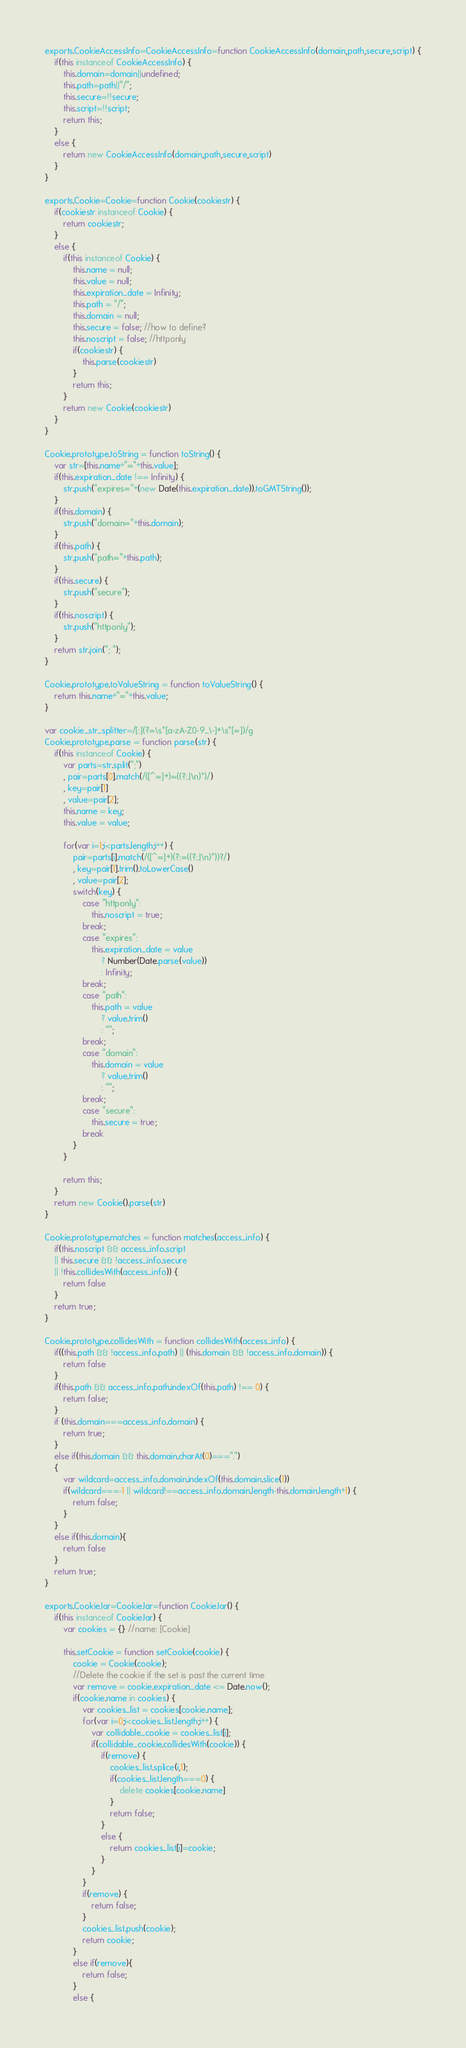<code> <loc_0><loc_0><loc_500><loc_500><_JavaScript_>exports.CookieAccessInfo=CookieAccessInfo=function CookieAccessInfo(domain,path,secure,script) {
    if(this instanceof CookieAccessInfo) {
    	this.domain=domain||undefined;
    	this.path=path||"/";
    	this.secure=!!secure;
    	this.script=!!script;
    	return this;
    }
    else {
        return new CookieAccessInfo(domain,path,secure,script)    
    }
}

exports.Cookie=Cookie=function Cookie(cookiestr) {
	if(cookiestr instanceof Cookie) {
		return cookiestr;
	}
    else {
        if(this instanceof Cookie) {
        	this.name = null;
        	this.value = null;
        	this.expiration_date = Infinity;
        	this.path = "/";
        	this.domain = null;
        	this.secure = false; //how to define?
        	this.noscript = false; //httponly
        	if(cookiestr) {
        		this.parse(cookiestr)
        	}
        	return this;
        }
        return new Cookie(cookiestr)
    }
}

Cookie.prototype.toString = function toString() {
	var str=[this.name+"="+this.value];
	if(this.expiration_date !== Infinity) {
		str.push("expires="+(new Date(this.expiration_date)).toGMTString());
	}
	if(this.domain) {
		str.push("domain="+this.domain);
	}
	if(this.path) {
		str.push("path="+this.path);
	}
	if(this.secure) {
		str.push("secure");
	}
	if(this.noscript) {
		str.push("httponly");
	}
	return str.join("; ");
}

Cookie.prototype.toValueString = function toValueString() {
	return this.name+"="+this.value;
}

var cookie_str_splitter=/[:](?=\s*[a-zA-Z0-9_\-]+\s*[=])/g
Cookie.prototype.parse = function parse(str) {
	if(this instanceof Cookie) {
    	var parts=str.split(";")
    	, pair=parts[0].match(/([^=]+)=((?:.|\n)*)/)
    	, key=pair[1]
    	, value=pair[2];
    	this.name = key;
    	this.value = value;
    
    	for(var i=1;i<parts.length;i++) {
    		pair=parts[i].match(/([^=]+)(?:=((?:.|\n)*))?/)
    		, key=pair[1].trim().toLowerCase()
    		, value=pair[2];
    		switch(key) {
    			case "httponly":
    				this.noscript = true;
    			break;
    			case "expires":
    				this.expiration_date = value
    					? Number(Date.parse(value))
    					: Infinity;
    			break;
    			case "path":
    				this.path = value
    					? value.trim()
    					: "";
    			break;
    			case "domain":
    				this.domain = value
    					? value.trim()
    					: "";
    			break;
    			case "secure":
    				this.secure = true;
    			break
    		}
    	}
    
    	return this;
	}
    return new Cookie().parse(str)
}

Cookie.prototype.matches = function matches(access_info) {
	if(this.noscript && access_info.script
	|| this.secure && !access_info.secure
	|| !this.collidesWith(access_info)) {
		return false
	}
	return true;
}

Cookie.prototype.collidesWith = function collidesWith(access_info) {
	if((this.path && !access_info.path) || (this.domain && !access_info.domain)) {
		return false
	}
	if(this.path && access_info.path.indexOf(this.path) !== 0) {
		return false;
	}
	if (this.domain===access_info.domain) {
		return true;
	}
	else if(this.domain && this.domain.charAt(0)===".")
	{
		var wildcard=access_info.domain.indexOf(this.domain.slice(1))
		if(wildcard===-1 || wildcard!==access_info.domain.length-this.domain.length+1) {
			return false;
		}
	}
	else if(this.domain){
		return false
	}
	return true;
}

exports.CookieJar=CookieJar=function CookieJar() {
	if(this instanceof CookieJar) {
    	var cookies = {} //name: [Cookie]
    
    	this.setCookie = function setCookie(cookie) {
    		cookie = Cookie(cookie);
    		//Delete the cookie if the set is past the current time
    		var remove = cookie.expiration_date <= Date.now();
    		if(cookie.name in cookies) {
    			var cookies_list = cookies[cookie.name];
    			for(var i=0;i<cookies_list.length;i++) {
    				var collidable_cookie = cookies_list[i];
    				if(collidable_cookie.collidesWith(cookie)) {
    					if(remove) {
    						cookies_list.splice(i,1);
    						if(cookies_list.length===0) {
    							delete cookies[cookie.name]
    						}
    						return false;
    					}
    					else {
    						return cookies_list[i]=cookie;
    					}
    				}
    			}
    			if(remove) {
    				return false;
    			}
    			cookies_list.push(cookie);
    			return cookie;
    		}
    		else if(remove){
    			return false;
    		}
    		else {</code> 